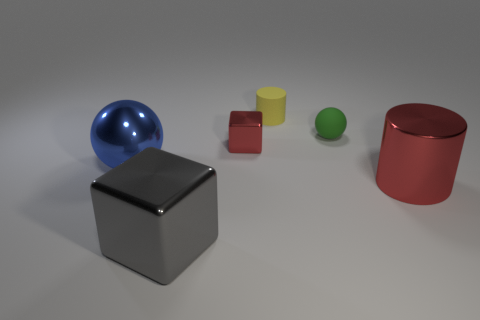Subtract all gray blocks. How many blocks are left? 1 Subtract all balls. How many objects are left? 4 Add 1 large yellow matte blocks. How many objects exist? 7 Add 4 small rubber spheres. How many small rubber spheres are left? 5 Add 5 large green blocks. How many large green blocks exist? 5 Subtract 0 green cubes. How many objects are left? 6 Subtract 1 blocks. How many blocks are left? 1 Subtract all yellow cylinders. Subtract all red blocks. How many cylinders are left? 1 Subtract all cyan blocks. How many cyan cylinders are left? 0 Subtract all gray objects. Subtract all large brown matte balls. How many objects are left? 5 